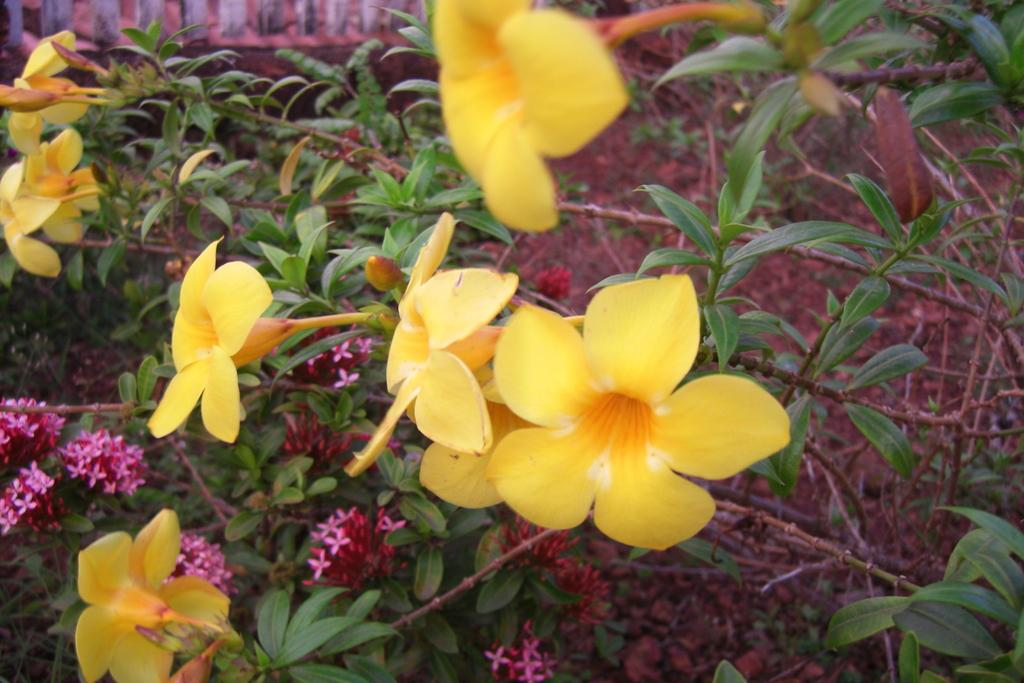What type of plants can be seen in the image? There are flowers in the image. What colors are present in the flowers? The flowers have yellow, pink, and red colors. What parts of the flowers are visible in the image? The flowers have leaves and stems. What type of hammer is being used to make a statement about the flowers in the image? There is no hammer or statement about the flowers in the image. 